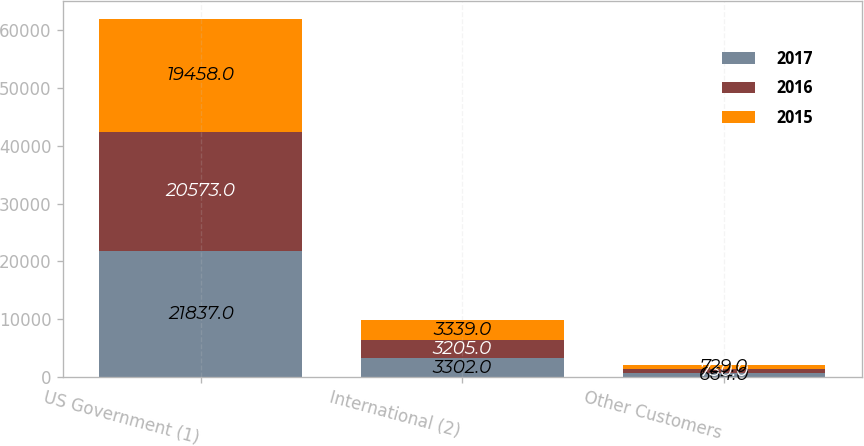Convert chart to OTSL. <chart><loc_0><loc_0><loc_500><loc_500><stacked_bar_chart><ecel><fcel>US Government (1)<fcel>International (2)<fcel>Other Customers<nl><fcel>2017<fcel>21837<fcel>3302<fcel>664<nl><fcel>2016<fcel>20573<fcel>3205<fcel>730<nl><fcel>2015<fcel>19458<fcel>3339<fcel>729<nl></chart> 